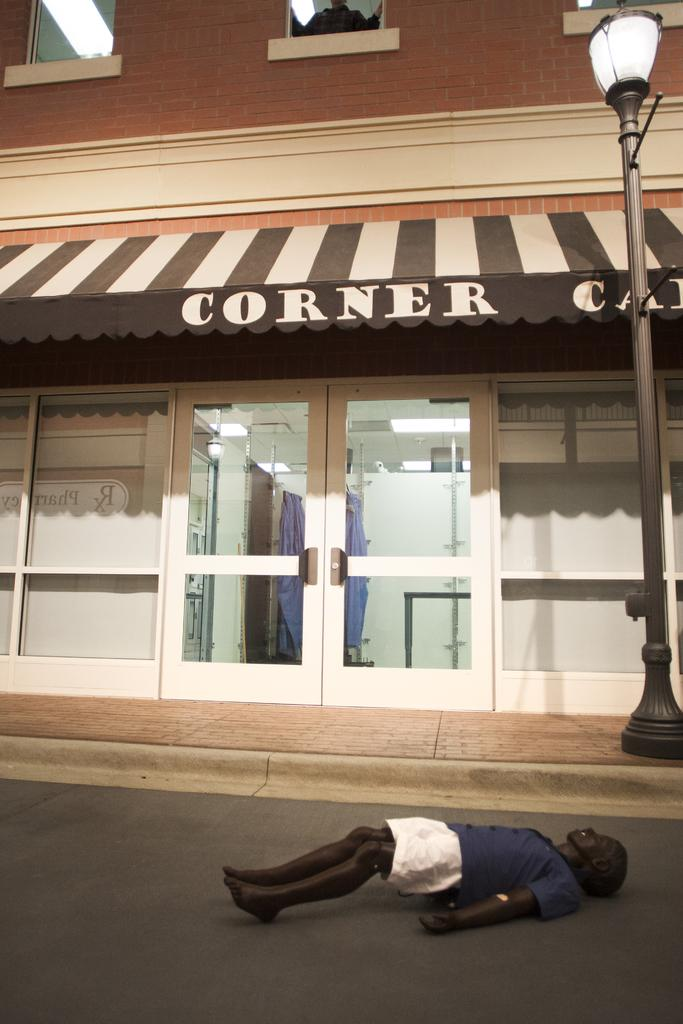What type of structure is present in the image? There is a building in the image. What type of establishment can be found within the building? There is a store in the image. What object is located at the bottom of the image? There is a toy at the bottom of the image. What can be seen on the right side of the image? There is a pole on the right side of the image. How many bees are buzzing around the store in the image? There are no bees present in the image. What type of war is depicted in the image? There is no war depicted in the image; it features a building with a store and other objects. 